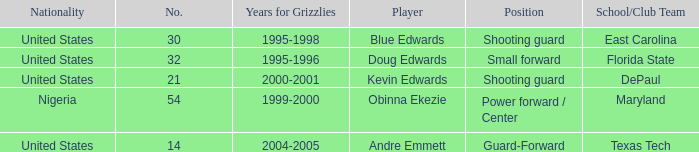What's the highest player number from the list from 2000-2001 21.0. 